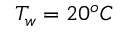Convert formula to latex. <formula><loc_0><loc_0><loc_500><loc_500>T _ { w } = 2 0 ^ { o } C</formula> 